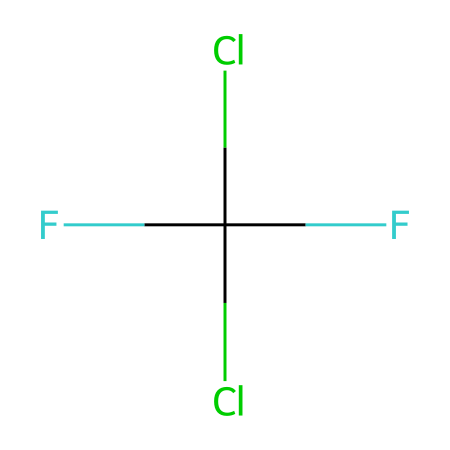What is the molecular formula of this chemical? Counting the atoms in the SMILES representation, we see there is 1 carbon (C), 2 chlorine (Cl), and 3 fluorine (F) atoms. Therefore, the molecular formula is CCl2F3.
Answer: CCl2F3 How many chlorine atoms are present in this compound? From the SMILES representation, we can identify 2 chlorine (Cl) atoms attached to the carbon atom.
Answer: 2 What type of bonds are present in this chemical? The structure indicates single bonds between the carbon and chlorine atoms as well as between the carbon and fluorine atoms. Therefore, all the bonds in this compound are single bonds.
Answer: single bonds What is the main use of this type of chemical? Chlorofluorocarbons (CFCs) like this compound are primarily used as refrigerants in older refrigeration systems.
Answer: refrigerants Is this compound considered environmentally friendly? Freon and other CFCs are known to be harmful to the ozone layer, making them environmentally harmful.
Answer: no What two elements does this refrigerant contain that are known to contribute to ozone depletion? The presence of chlorine (Cl) and bromine (Br) in the structure is known to contribute to ozone depletion. In this case, only chlorine is represented.
Answer: chlorine What phase (gas, liquid, solid) does this type of refrigerant typically exist in within refrigeration systems? CFCs like this compound typically exist in a gaseous phase during refrigeration cycles but can be compressed into liquids.
Answer: gas 